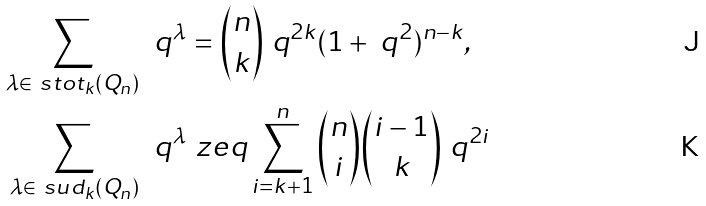<formula> <loc_0><loc_0><loc_500><loc_500>\sum _ { \lambda \in \ s t o t _ { k } ( Q _ { n } ) } \, \ q ^ { \lambda } & = \binom { n } { k } \ q ^ { 2 k } ( 1 + \ q ^ { 2 } ) ^ { n - k } , \\ \sum _ { \lambda \in \ s u d _ { k } ( Q _ { n } ) } \, \ q ^ { \lambda } & \ z e q \sum _ { i = k + 1 } ^ { n } \binom { n } { i } \binom { i - 1 } { k } \ q ^ { 2 i }</formula> 